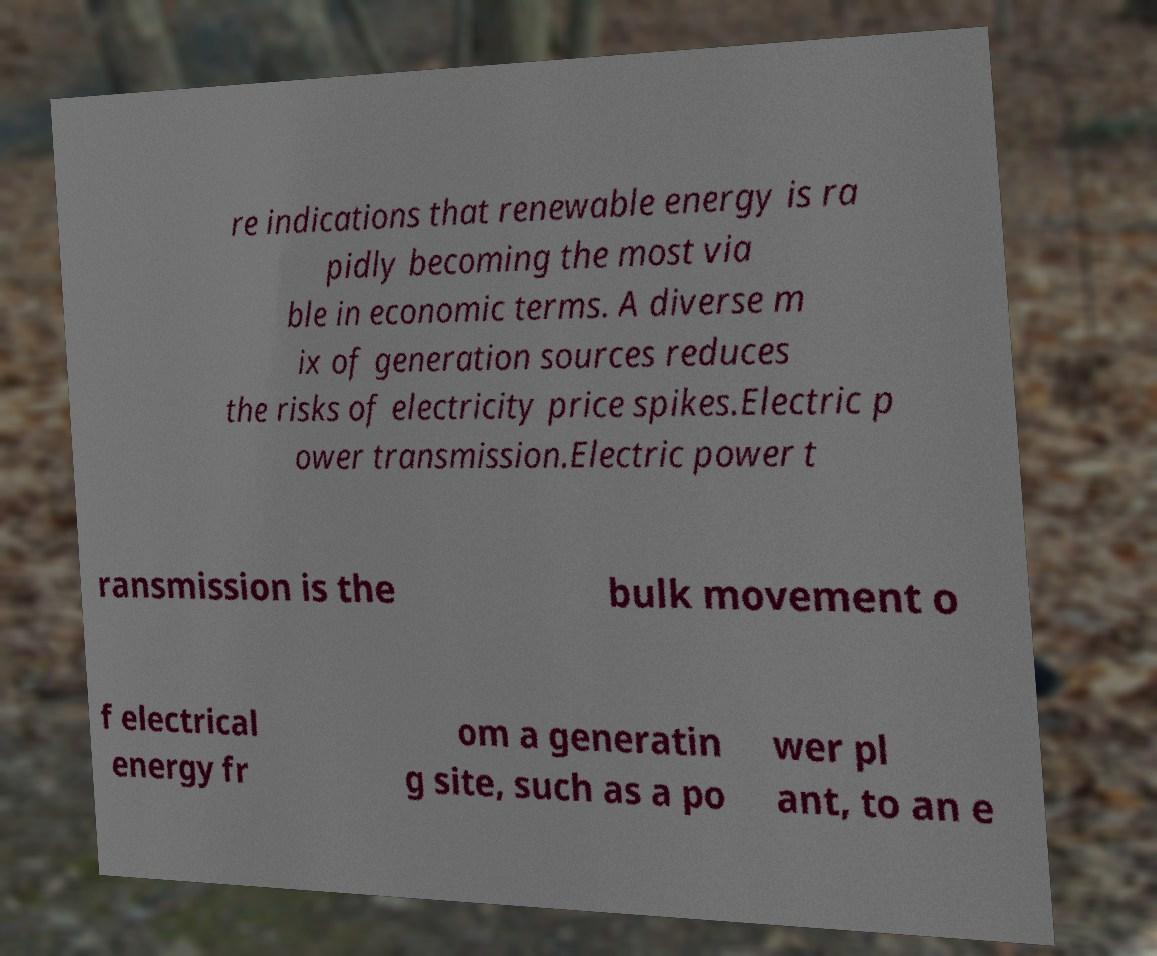Could you extract and type out the text from this image? re indications that renewable energy is ra pidly becoming the most via ble in economic terms. A diverse m ix of generation sources reduces the risks of electricity price spikes.Electric p ower transmission.Electric power t ransmission is the bulk movement o f electrical energy fr om a generatin g site, such as a po wer pl ant, to an e 